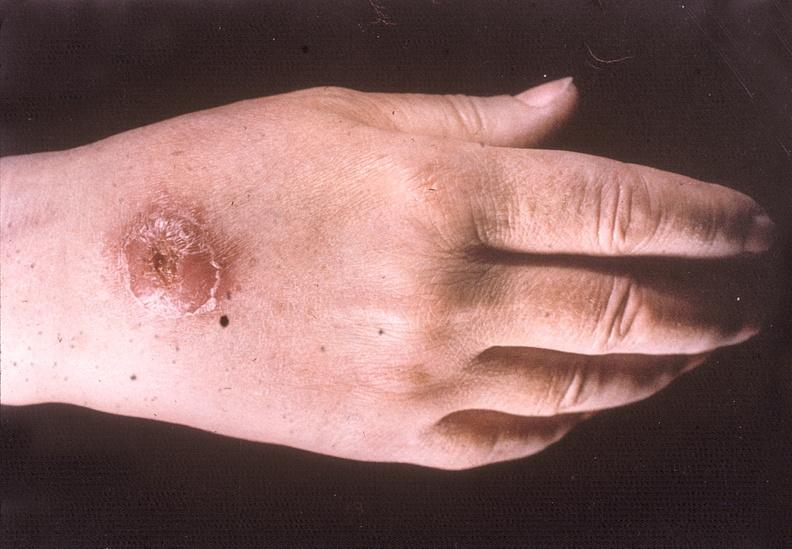does child show hand, cutaneous leishmaniasis kala-azar?
Answer the question using a single word or phrase. No 